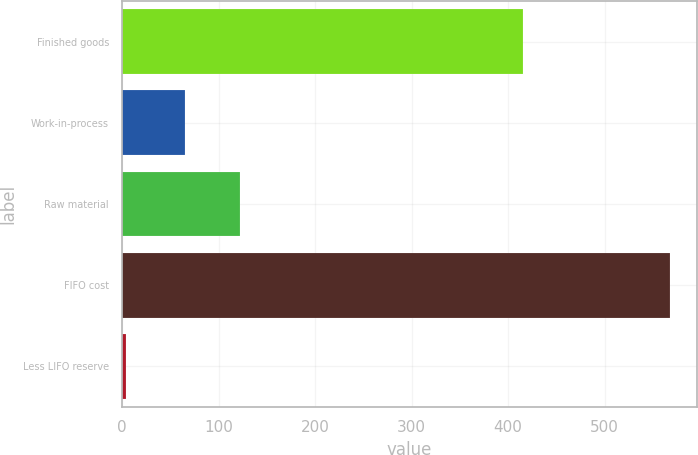Convert chart. <chart><loc_0><loc_0><loc_500><loc_500><bar_chart><fcel>Finished goods<fcel>Work-in-process<fcel>Raw material<fcel>FIFO cost<fcel>Less LIFO reserve<nl><fcel>414.9<fcel>65.4<fcel>121.75<fcel>567.3<fcel>3.8<nl></chart> 